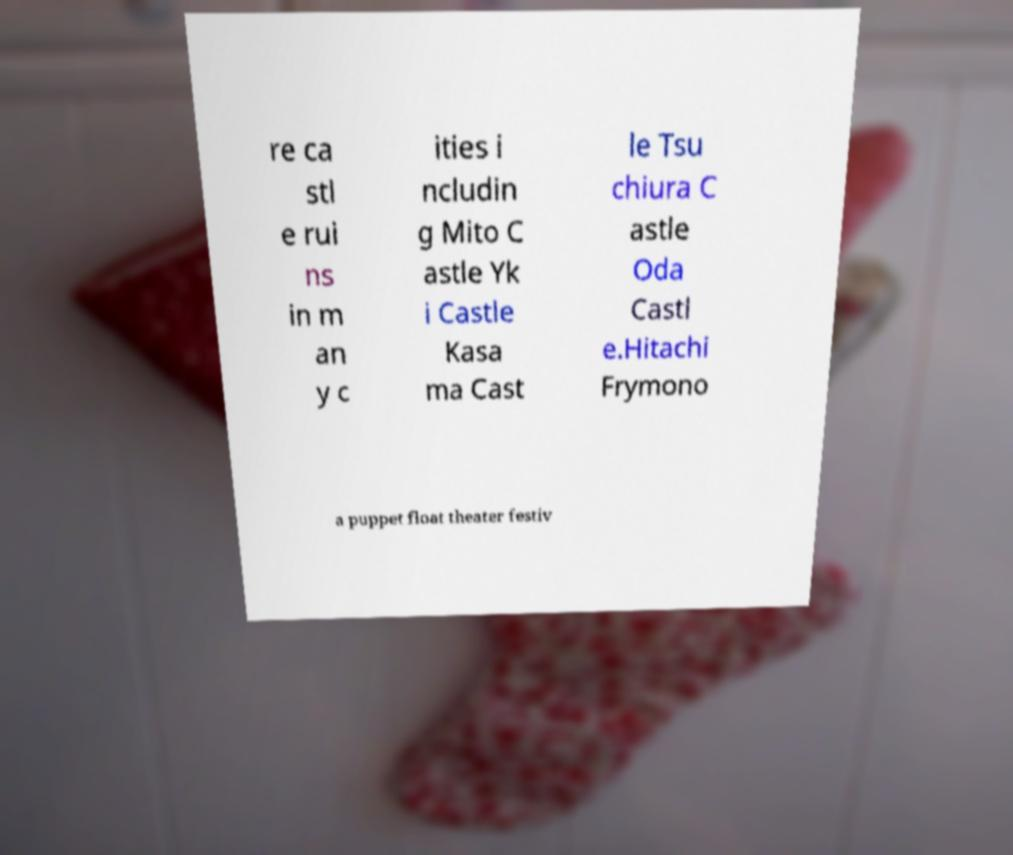Please read and relay the text visible in this image. What does it say? re ca stl e rui ns in m an y c ities i ncludin g Mito C astle Yk i Castle Kasa ma Cast le Tsu chiura C astle Oda Castl e.Hitachi Frymono a puppet float theater festiv 